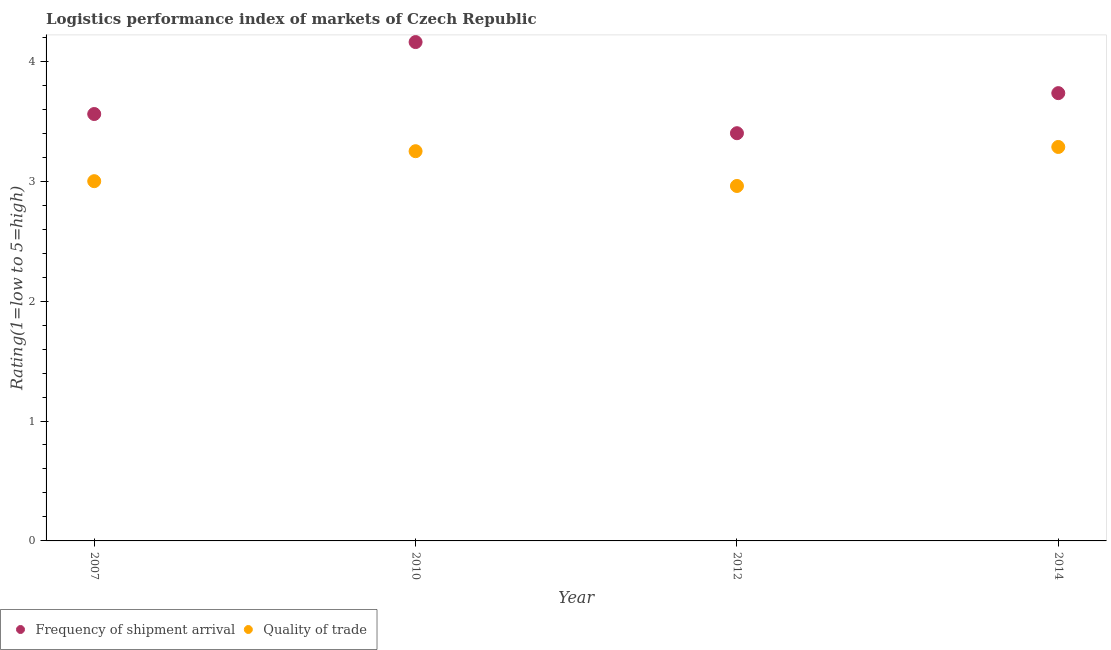Is the number of dotlines equal to the number of legend labels?
Your answer should be very brief. Yes. Across all years, what is the maximum lpi of frequency of shipment arrival?
Provide a short and direct response. 4.16. What is the total lpi of frequency of shipment arrival in the graph?
Provide a succinct answer. 14.85. What is the difference between the lpi quality of trade in 2007 and the lpi of frequency of shipment arrival in 2010?
Provide a short and direct response. -1.16. What is the average lpi quality of trade per year?
Make the answer very short. 3.12. In the year 2007, what is the difference between the lpi of frequency of shipment arrival and lpi quality of trade?
Keep it short and to the point. 0.56. In how many years, is the lpi of frequency of shipment arrival greater than 2.2?
Your answer should be very brief. 4. What is the ratio of the lpi quality of trade in 2012 to that in 2014?
Provide a succinct answer. 0.9. What is the difference between the highest and the second highest lpi quality of trade?
Make the answer very short. 0.04. What is the difference between the highest and the lowest lpi quality of trade?
Provide a succinct answer. 0.33. In how many years, is the lpi of frequency of shipment arrival greater than the average lpi of frequency of shipment arrival taken over all years?
Your answer should be very brief. 2. Is the sum of the lpi quality of trade in 2010 and 2012 greater than the maximum lpi of frequency of shipment arrival across all years?
Offer a very short reply. Yes. Does the lpi of frequency of shipment arrival monotonically increase over the years?
Provide a succinct answer. No. How many years are there in the graph?
Your answer should be very brief. 4. Does the graph contain any zero values?
Offer a very short reply. No. How many legend labels are there?
Keep it short and to the point. 2. What is the title of the graph?
Give a very brief answer. Logistics performance index of markets of Czech Republic. What is the label or title of the Y-axis?
Your response must be concise. Rating(1=low to 5=high). What is the Rating(1=low to 5=high) of Frequency of shipment arrival in 2007?
Offer a very short reply. 3.56. What is the Rating(1=low to 5=high) of Frequency of shipment arrival in 2010?
Offer a very short reply. 4.16. What is the Rating(1=low to 5=high) in Frequency of shipment arrival in 2012?
Give a very brief answer. 3.4. What is the Rating(1=low to 5=high) in Quality of trade in 2012?
Your response must be concise. 2.96. What is the Rating(1=low to 5=high) of Frequency of shipment arrival in 2014?
Give a very brief answer. 3.73. What is the Rating(1=low to 5=high) of Quality of trade in 2014?
Provide a succinct answer. 3.29. Across all years, what is the maximum Rating(1=low to 5=high) of Frequency of shipment arrival?
Ensure brevity in your answer.  4.16. Across all years, what is the maximum Rating(1=low to 5=high) of Quality of trade?
Provide a short and direct response. 3.29. Across all years, what is the minimum Rating(1=low to 5=high) of Frequency of shipment arrival?
Your answer should be compact. 3.4. Across all years, what is the minimum Rating(1=low to 5=high) of Quality of trade?
Offer a very short reply. 2.96. What is the total Rating(1=low to 5=high) in Frequency of shipment arrival in the graph?
Your answer should be compact. 14.85. What is the total Rating(1=low to 5=high) of Quality of trade in the graph?
Your response must be concise. 12.5. What is the difference between the Rating(1=low to 5=high) in Frequency of shipment arrival in 2007 and that in 2010?
Your answer should be compact. -0.6. What is the difference between the Rating(1=low to 5=high) of Quality of trade in 2007 and that in 2010?
Provide a succinct answer. -0.25. What is the difference between the Rating(1=low to 5=high) of Frequency of shipment arrival in 2007 and that in 2012?
Your response must be concise. 0.16. What is the difference between the Rating(1=low to 5=high) of Quality of trade in 2007 and that in 2012?
Provide a short and direct response. 0.04. What is the difference between the Rating(1=low to 5=high) in Frequency of shipment arrival in 2007 and that in 2014?
Offer a very short reply. -0.17. What is the difference between the Rating(1=low to 5=high) in Quality of trade in 2007 and that in 2014?
Your response must be concise. -0.29. What is the difference between the Rating(1=low to 5=high) in Frequency of shipment arrival in 2010 and that in 2012?
Your response must be concise. 0.76. What is the difference between the Rating(1=low to 5=high) in Quality of trade in 2010 and that in 2012?
Your answer should be very brief. 0.29. What is the difference between the Rating(1=low to 5=high) in Frequency of shipment arrival in 2010 and that in 2014?
Offer a terse response. 0.43. What is the difference between the Rating(1=low to 5=high) of Quality of trade in 2010 and that in 2014?
Give a very brief answer. -0.04. What is the difference between the Rating(1=low to 5=high) of Frequency of shipment arrival in 2012 and that in 2014?
Give a very brief answer. -0.33. What is the difference between the Rating(1=low to 5=high) in Quality of trade in 2012 and that in 2014?
Keep it short and to the point. -0.33. What is the difference between the Rating(1=low to 5=high) of Frequency of shipment arrival in 2007 and the Rating(1=low to 5=high) of Quality of trade in 2010?
Offer a terse response. 0.31. What is the difference between the Rating(1=low to 5=high) in Frequency of shipment arrival in 2007 and the Rating(1=low to 5=high) in Quality of trade in 2014?
Your answer should be compact. 0.27. What is the difference between the Rating(1=low to 5=high) in Frequency of shipment arrival in 2010 and the Rating(1=low to 5=high) in Quality of trade in 2014?
Provide a short and direct response. 0.87. What is the difference between the Rating(1=low to 5=high) of Frequency of shipment arrival in 2012 and the Rating(1=low to 5=high) of Quality of trade in 2014?
Ensure brevity in your answer.  0.11. What is the average Rating(1=low to 5=high) of Frequency of shipment arrival per year?
Keep it short and to the point. 3.71. What is the average Rating(1=low to 5=high) in Quality of trade per year?
Keep it short and to the point. 3.12. In the year 2007, what is the difference between the Rating(1=low to 5=high) of Frequency of shipment arrival and Rating(1=low to 5=high) of Quality of trade?
Keep it short and to the point. 0.56. In the year 2010, what is the difference between the Rating(1=low to 5=high) in Frequency of shipment arrival and Rating(1=low to 5=high) in Quality of trade?
Offer a very short reply. 0.91. In the year 2012, what is the difference between the Rating(1=low to 5=high) in Frequency of shipment arrival and Rating(1=low to 5=high) in Quality of trade?
Your answer should be very brief. 0.44. In the year 2014, what is the difference between the Rating(1=low to 5=high) in Frequency of shipment arrival and Rating(1=low to 5=high) in Quality of trade?
Provide a succinct answer. 0.45. What is the ratio of the Rating(1=low to 5=high) of Frequency of shipment arrival in 2007 to that in 2010?
Provide a short and direct response. 0.86. What is the ratio of the Rating(1=low to 5=high) of Frequency of shipment arrival in 2007 to that in 2012?
Provide a succinct answer. 1.05. What is the ratio of the Rating(1=low to 5=high) in Quality of trade in 2007 to that in 2012?
Make the answer very short. 1.01. What is the ratio of the Rating(1=low to 5=high) of Frequency of shipment arrival in 2007 to that in 2014?
Your answer should be compact. 0.95. What is the ratio of the Rating(1=low to 5=high) in Quality of trade in 2007 to that in 2014?
Your response must be concise. 0.91. What is the ratio of the Rating(1=low to 5=high) of Frequency of shipment arrival in 2010 to that in 2012?
Offer a very short reply. 1.22. What is the ratio of the Rating(1=low to 5=high) of Quality of trade in 2010 to that in 2012?
Your response must be concise. 1.1. What is the ratio of the Rating(1=low to 5=high) of Frequency of shipment arrival in 2010 to that in 2014?
Your answer should be very brief. 1.11. What is the ratio of the Rating(1=low to 5=high) in Quality of trade in 2010 to that in 2014?
Give a very brief answer. 0.99. What is the ratio of the Rating(1=low to 5=high) of Frequency of shipment arrival in 2012 to that in 2014?
Your answer should be compact. 0.91. What is the ratio of the Rating(1=low to 5=high) of Quality of trade in 2012 to that in 2014?
Your answer should be very brief. 0.9. What is the difference between the highest and the second highest Rating(1=low to 5=high) in Frequency of shipment arrival?
Make the answer very short. 0.43. What is the difference between the highest and the second highest Rating(1=low to 5=high) in Quality of trade?
Provide a succinct answer. 0.04. What is the difference between the highest and the lowest Rating(1=low to 5=high) in Frequency of shipment arrival?
Keep it short and to the point. 0.76. What is the difference between the highest and the lowest Rating(1=low to 5=high) in Quality of trade?
Offer a terse response. 0.33. 